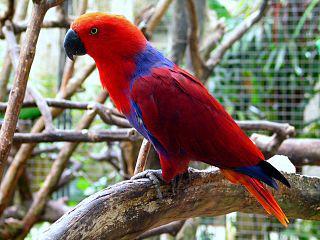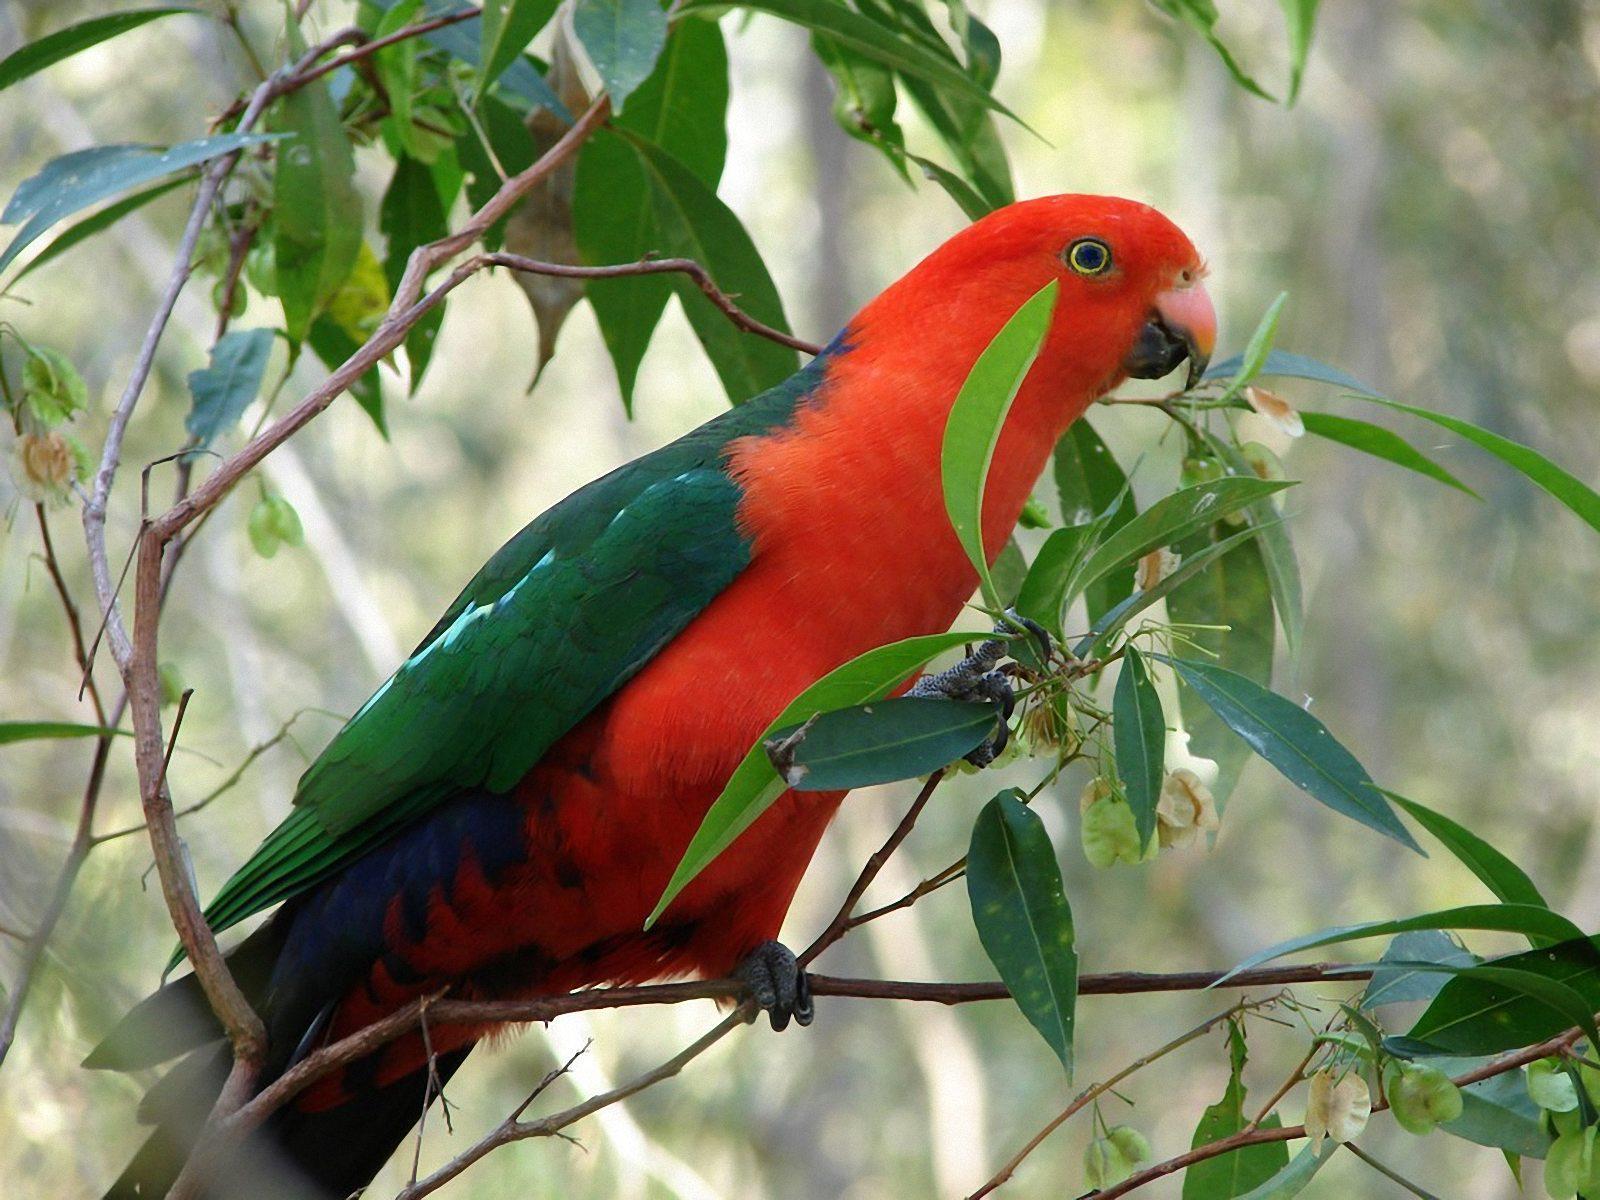The first image is the image on the left, the second image is the image on the right. Evaluate the accuracy of this statement regarding the images: "The parrot furthest on the left is facing in the left direction.". Is it true? Answer yes or no. Yes. The first image is the image on the left, the second image is the image on the right. For the images displayed, is the sentence "In one of the images, the birds are only shown as profile." factually correct? Answer yes or no. Yes. 